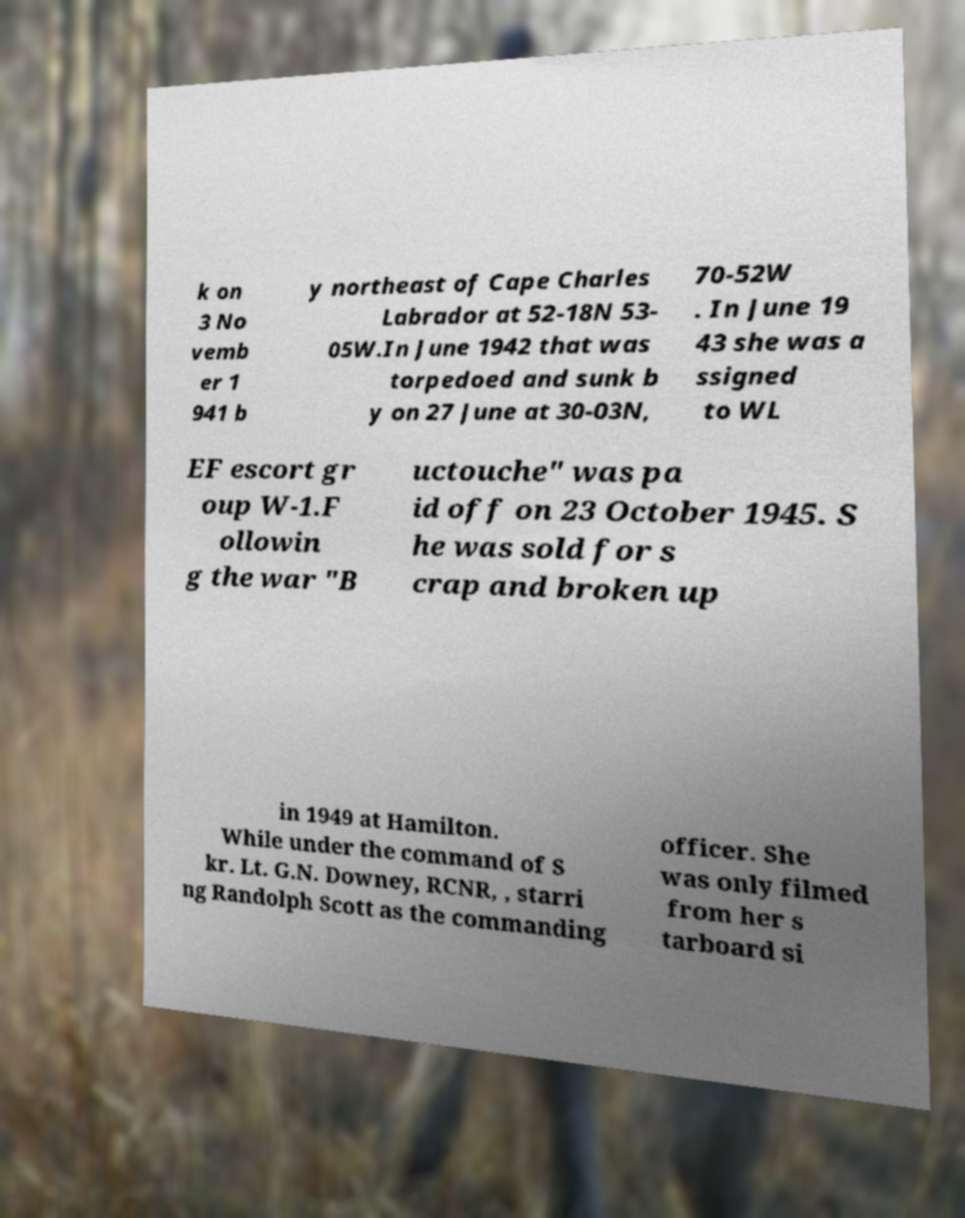Please identify and transcribe the text found in this image. k on 3 No vemb er 1 941 b y northeast of Cape Charles Labrador at 52-18N 53- 05W.In June 1942 that was torpedoed and sunk b y on 27 June at 30-03N, 70-52W . In June 19 43 she was a ssigned to WL EF escort gr oup W-1.F ollowin g the war "B uctouche" was pa id off on 23 October 1945. S he was sold for s crap and broken up in 1949 at Hamilton. While under the command of S kr. Lt. G.N. Downey, RCNR, , starri ng Randolph Scott as the commanding officer. She was only filmed from her s tarboard si 